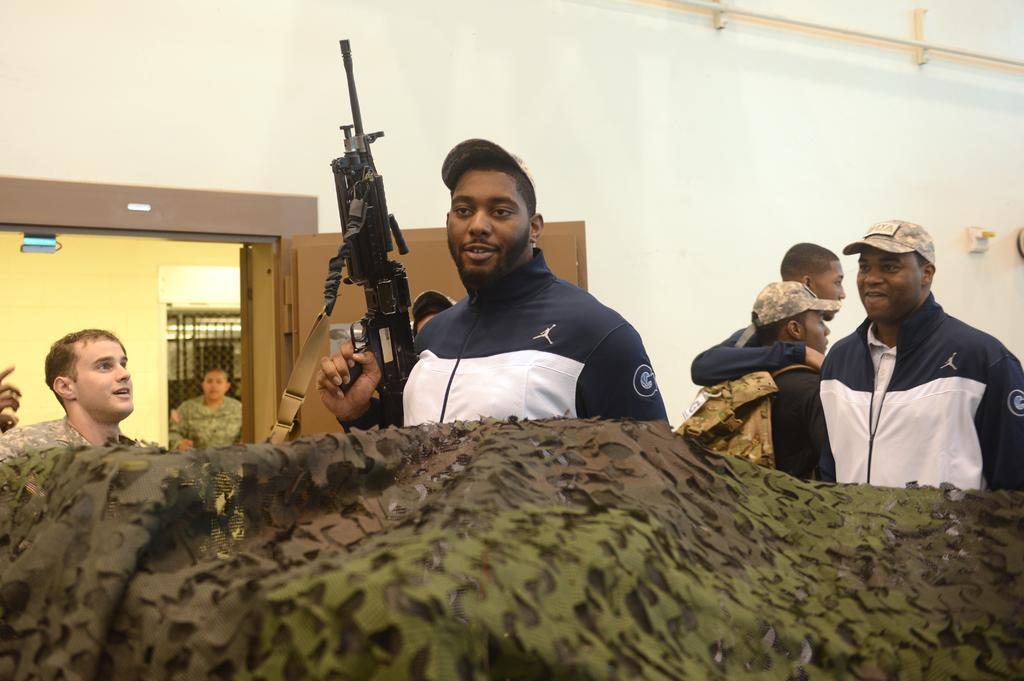Can you describe this image briefly? In this picture I can see a person holding the machine gun. I can see people standing. I can see the door. 